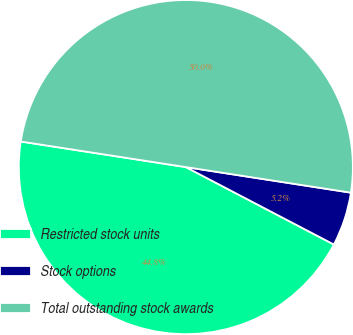Convert chart to OTSL. <chart><loc_0><loc_0><loc_500><loc_500><pie_chart><fcel>Restricted stock units<fcel>Stock options<fcel>Total outstanding stock awards<nl><fcel>44.78%<fcel>5.22%<fcel>50.0%<nl></chart> 